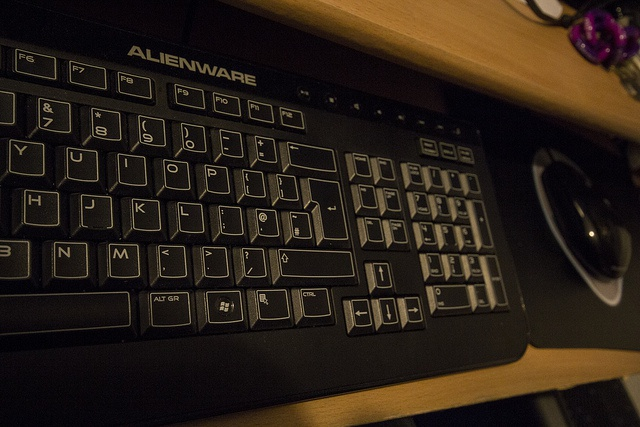Describe the objects in this image and their specific colors. I can see keyboard in black and gray tones and mouse in black, gray, and khaki tones in this image. 